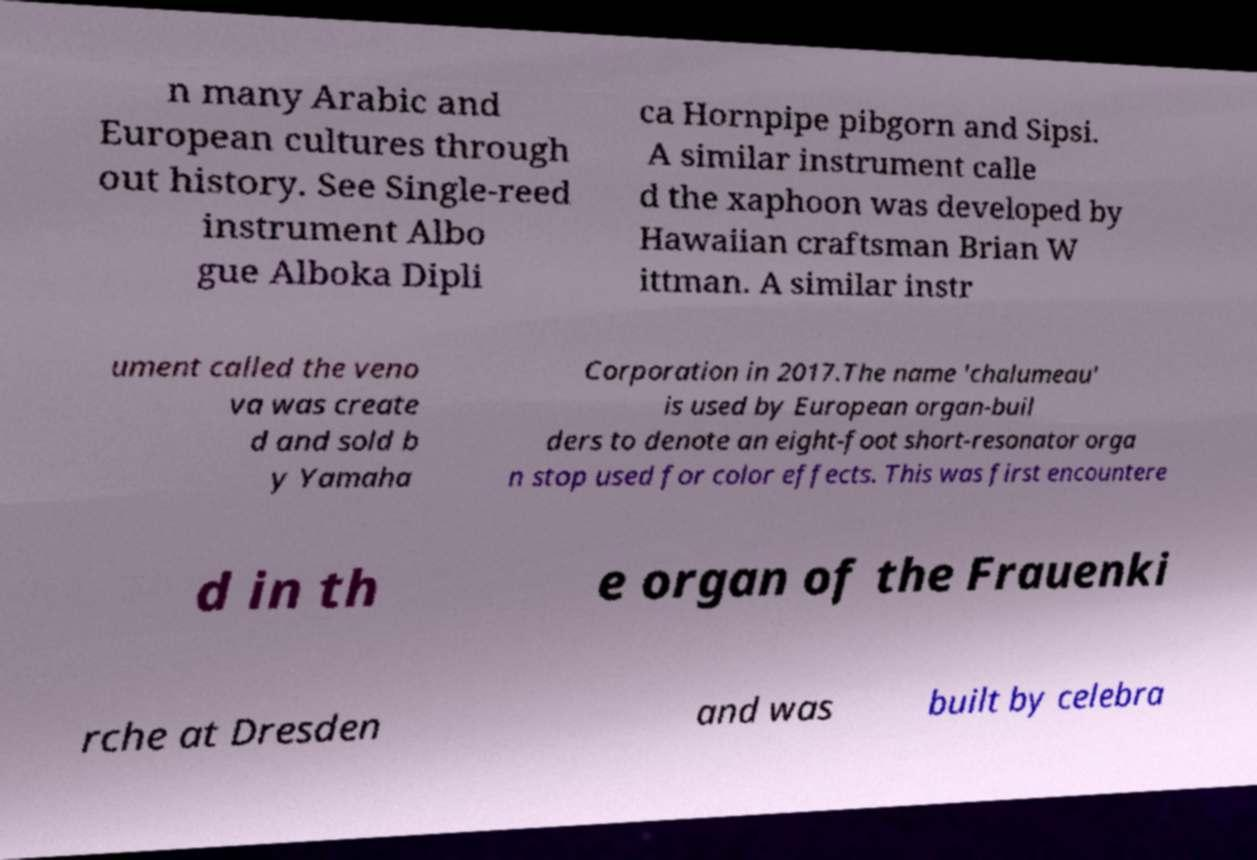Can you read and provide the text displayed in the image?This photo seems to have some interesting text. Can you extract and type it out for me? n many Arabic and European cultures through out history. See Single-reed instrument Albo gue Alboka Dipli ca Hornpipe pibgorn and Sipsi. A similar instrument calle d the xaphoon was developed by Hawaiian craftsman Brian W ittman. A similar instr ument called the veno va was create d and sold b y Yamaha Corporation in 2017.The name 'chalumeau' is used by European organ-buil ders to denote an eight-foot short-resonator orga n stop used for color effects. This was first encountere d in th e organ of the Frauenki rche at Dresden and was built by celebra 